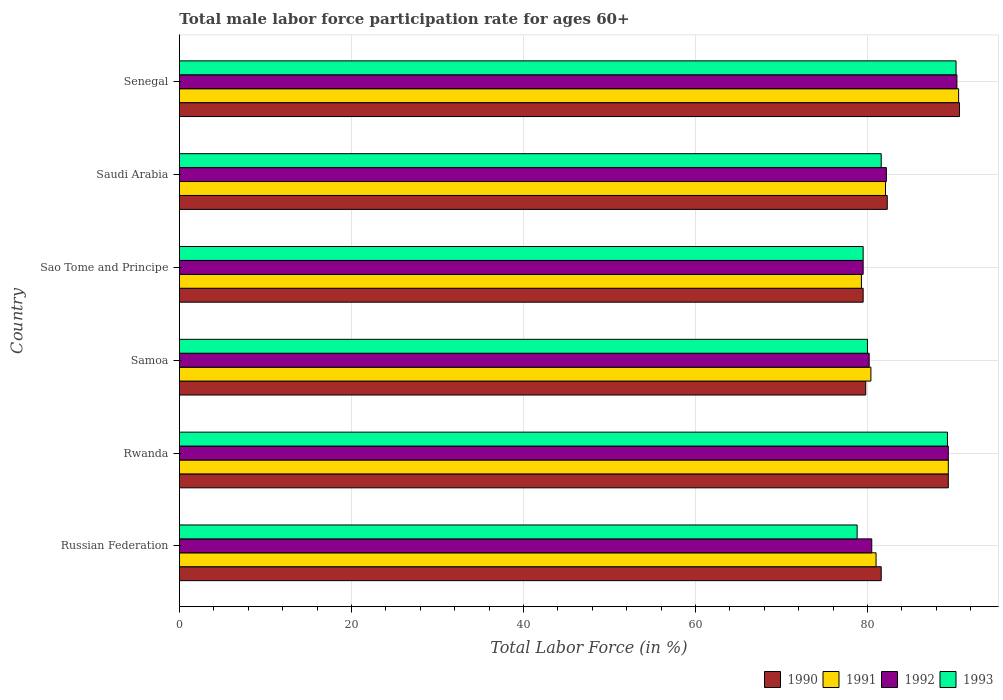How many groups of bars are there?
Offer a very short reply. 6. Are the number of bars per tick equal to the number of legend labels?
Provide a succinct answer. Yes. How many bars are there on the 6th tick from the top?
Give a very brief answer. 4. What is the label of the 4th group of bars from the top?
Keep it short and to the point. Samoa. What is the male labor force participation rate in 1993 in Senegal?
Keep it short and to the point. 90.3. Across all countries, what is the maximum male labor force participation rate in 1992?
Your response must be concise. 90.4. Across all countries, what is the minimum male labor force participation rate in 1993?
Make the answer very short. 78.8. In which country was the male labor force participation rate in 1993 maximum?
Offer a very short reply. Senegal. In which country was the male labor force participation rate in 1993 minimum?
Your answer should be compact. Russian Federation. What is the total male labor force participation rate in 1993 in the graph?
Offer a terse response. 499.5. What is the difference between the male labor force participation rate in 1992 in Samoa and that in Sao Tome and Principe?
Offer a very short reply. 0.7. What is the difference between the male labor force participation rate in 1991 in Senegal and the male labor force participation rate in 1992 in Samoa?
Your answer should be compact. 10.4. What is the average male labor force participation rate in 1992 per country?
Keep it short and to the point. 83.7. What is the difference between the male labor force participation rate in 1991 and male labor force participation rate in 1993 in Samoa?
Offer a very short reply. 0.4. What is the ratio of the male labor force participation rate in 1992 in Russian Federation to that in Saudi Arabia?
Provide a short and direct response. 0.98. What is the difference between the highest and the second highest male labor force participation rate in 1990?
Offer a very short reply. 1.3. What does the 4th bar from the top in Samoa represents?
Your answer should be compact. 1990. What does the 1st bar from the bottom in Saudi Arabia represents?
Your answer should be compact. 1990. Is it the case that in every country, the sum of the male labor force participation rate in 1992 and male labor force participation rate in 1991 is greater than the male labor force participation rate in 1990?
Ensure brevity in your answer.  Yes. How many bars are there?
Offer a very short reply. 24. How many countries are there in the graph?
Provide a short and direct response. 6. Does the graph contain grids?
Offer a terse response. Yes. Where does the legend appear in the graph?
Provide a succinct answer. Bottom right. How are the legend labels stacked?
Your answer should be very brief. Horizontal. What is the title of the graph?
Your answer should be very brief. Total male labor force participation rate for ages 60+. Does "2003" appear as one of the legend labels in the graph?
Your response must be concise. No. What is the label or title of the Y-axis?
Provide a short and direct response. Country. What is the Total Labor Force (in %) of 1990 in Russian Federation?
Keep it short and to the point. 81.6. What is the Total Labor Force (in %) in 1991 in Russian Federation?
Keep it short and to the point. 81. What is the Total Labor Force (in %) in 1992 in Russian Federation?
Ensure brevity in your answer.  80.5. What is the Total Labor Force (in %) in 1993 in Russian Federation?
Provide a short and direct response. 78.8. What is the Total Labor Force (in %) of 1990 in Rwanda?
Give a very brief answer. 89.4. What is the Total Labor Force (in %) in 1991 in Rwanda?
Your answer should be compact. 89.4. What is the Total Labor Force (in %) in 1992 in Rwanda?
Provide a succinct answer. 89.4. What is the Total Labor Force (in %) of 1993 in Rwanda?
Make the answer very short. 89.3. What is the Total Labor Force (in %) of 1990 in Samoa?
Offer a very short reply. 79.8. What is the Total Labor Force (in %) of 1991 in Samoa?
Make the answer very short. 80.4. What is the Total Labor Force (in %) of 1992 in Samoa?
Offer a terse response. 80.2. What is the Total Labor Force (in %) in 1990 in Sao Tome and Principe?
Ensure brevity in your answer.  79.5. What is the Total Labor Force (in %) in 1991 in Sao Tome and Principe?
Provide a short and direct response. 79.3. What is the Total Labor Force (in %) of 1992 in Sao Tome and Principe?
Your answer should be compact. 79.5. What is the Total Labor Force (in %) in 1993 in Sao Tome and Principe?
Provide a short and direct response. 79.5. What is the Total Labor Force (in %) in 1990 in Saudi Arabia?
Your answer should be very brief. 82.3. What is the Total Labor Force (in %) in 1991 in Saudi Arabia?
Ensure brevity in your answer.  82.1. What is the Total Labor Force (in %) in 1992 in Saudi Arabia?
Ensure brevity in your answer.  82.2. What is the Total Labor Force (in %) of 1993 in Saudi Arabia?
Give a very brief answer. 81.6. What is the Total Labor Force (in %) in 1990 in Senegal?
Offer a terse response. 90.7. What is the Total Labor Force (in %) of 1991 in Senegal?
Your response must be concise. 90.6. What is the Total Labor Force (in %) of 1992 in Senegal?
Ensure brevity in your answer.  90.4. What is the Total Labor Force (in %) in 1993 in Senegal?
Offer a terse response. 90.3. Across all countries, what is the maximum Total Labor Force (in %) in 1990?
Ensure brevity in your answer.  90.7. Across all countries, what is the maximum Total Labor Force (in %) of 1991?
Provide a short and direct response. 90.6. Across all countries, what is the maximum Total Labor Force (in %) in 1992?
Ensure brevity in your answer.  90.4. Across all countries, what is the maximum Total Labor Force (in %) in 1993?
Provide a short and direct response. 90.3. Across all countries, what is the minimum Total Labor Force (in %) of 1990?
Your response must be concise. 79.5. Across all countries, what is the minimum Total Labor Force (in %) of 1991?
Keep it short and to the point. 79.3. Across all countries, what is the minimum Total Labor Force (in %) in 1992?
Your response must be concise. 79.5. Across all countries, what is the minimum Total Labor Force (in %) in 1993?
Give a very brief answer. 78.8. What is the total Total Labor Force (in %) of 1990 in the graph?
Provide a short and direct response. 503.3. What is the total Total Labor Force (in %) of 1991 in the graph?
Your answer should be very brief. 502.8. What is the total Total Labor Force (in %) of 1992 in the graph?
Your response must be concise. 502.2. What is the total Total Labor Force (in %) of 1993 in the graph?
Keep it short and to the point. 499.5. What is the difference between the Total Labor Force (in %) of 1991 in Russian Federation and that in Rwanda?
Provide a short and direct response. -8.4. What is the difference between the Total Labor Force (in %) of 1993 in Russian Federation and that in Rwanda?
Your response must be concise. -10.5. What is the difference between the Total Labor Force (in %) in 1990 in Russian Federation and that in Samoa?
Your answer should be compact. 1.8. What is the difference between the Total Labor Force (in %) of 1990 in Russian Federation and that in Sao Tome and Principe?
Ensure brevity in your answer.  2.1. What is the difference between the Total Labor Force (in %) of 1991 in Russian Federation and that in Sao Tome and Principe?
Make the answer very short. 1.7. What is the difference between the Total Labor Force (in %) in 1992 in Russian Federation and that in Sao Tome and Principe?
Your response must be concise. 1. What is the difference between the Total Labor Force (in %) in 1993 in Russian Federation and that in Sao Tome and Principe?
Offer a terse response. -0.7. What is the difference between the Total Labor Force (in %) of 1993 in Russian Federation and that in Saudi Arabia?
Offer a very short reply. -2.8. What is the difference between the Total Labor Force (in %) in 1990 in Russian Federation and that in Senegal?
Ensure brevity in your answer.  -9.1. What is the difference between the Total Labor Force (in %) in 1991 in Russian Federation and that in Senegal?
Give a very brief answer. -9.6. What is the difference between the Total Labor Force (in %) in 1992 in Rwanda and that in Samoa?
Offer a terse response. 9.2. What is the difference between the Total Labor Force (in %) in 1990 in Rwanda and that in Sao Tome and Principe?
Keep it short and to the point. 9.9. What is the difference between the Total Labor Force (in %) of 1991 in Rwanda and that in Sao Tome and Principe?
Provide a short and direct response. 10.1. What is the difference between the Total Labor Force (in %) of 1990 in Rwanda and that in Saudi Arabia?
Your response must be concise. 7.1. What is the difference between the Total Labor Force (in %) of 1992 in Rwanda and that in Saudi Arabia?
Offer a very short reply. 7.2. What is the difference between the Total Labor Force (in %) of 1993 in Rwanda and that in Saudi Arabia?
Ensure brevity in your answer.  7.7. What is the difference between the Total Labor Force (in %) of 1990 in Rwanda and that in Senegal?
Offer a very short reply. -1.3. What is the difference between the Total Labor Force (in %) of 1991 in Rwanda and that in Senegal?
Offer a terse response. -1.2. What is the difference between the Total Labor Force (in %) in 1992 in Rwanda and that in Senegal?
Make the answer very short. -1. What is the difference between the Total Labor Force (in %) of 1990 in Samoa and that in Sao Tome and Principe?
Make the answer very short. 0.3. What is the difference between the Total Labor Force (in %) of 1993 in Samoa and that in Sao Tome and Principe?
Offer a terse response. 0.5. What is the difference between the Total Labor Force (in %) of 1990 in Samoa and that in Saudi Arabia?
Make the answer very short. -2.5. What is the difference between the Total Labor Force (in %) of 1990 in Samoa and that in Senegal?
Make the answer very short. -10.9. What is the difference between the Total Labor Force (in %) in 1992 in Samoa and that in Senegal?
Keep it short and to the point. -10.2. What is the difference between the Total Labor Force (in %) of 1990 in Sao Tome and Principe and that in Saudi Arabia?
Ensure brevity in your answer.  -2.8. What is the difference between the Total Labor Force (in %) of 1992 in Sao Tome and Principe and that in Saudi Arabia?
Make the answer very short. -2.7. What is the difference between the Total Labor Force (in %) of 1993 in Sao Tome and Principe and that in Saudi Arabia?
Provide a short and direct response. -2.1. What is the difference between the Total Labor Force (in %) in 1991 in Sao Tome and Principe and that in Senegal?
Provide a short and direct response. -11.3. What is the difference between the Total Labor Force (in %) in 1992 in Sao Tome and Principe and that in Senegal?
Offer a very short reply. -10.9. What is the difference between the Total Labor Force (in %) in 1993 in Sao Tome and Principe and that in Senegal?
Your response must be concise. -10.8. What is the difference between the Total Labor Force (in %) of 1991 in Saudi Arabia and that in Senegal?
Keep it short and to the point. -8.5. What is the difference between the Total Labor Force (in %) in 1992 in Saudi Arabia and that in Senegal?
Make the answer very short. -8.2. What is the difference between the Total Labor Force (in %) of 1993 in Saudi Arabia and that in Senegal?
Your response must be concise. -8.7. What is the difference between the Total Labor Force (in %) in 1990 in Russian Federation and the Total Labor Force (in %) in 1992 in Rwanda?
Ensure brevity in your answer.  -7.8. What is the difference between the Total Labor Force (in %) in 1990 in Russian Federation and the Total Labor Force (in %) in 1993 in Rwanda?
Offer a very short reply. -7.7. What is the difference between the Total Labor Force (in %) of 1991 in Russian Federation and the Total Labor Force (in %) of 1993 in Rwanda?
Provide a succinct answer. -8.3. What is the difference between the Total Labor Force (in %) in 1990 in Russian Federation and the Total Labor Force (in %) in 1992 in Samoa?
Offer a very short reply. 1.4. What is the difference between the Total Labor Force (in %) of 1991 in Russian Federation and the Total Labor Force (in %) of 1992 in Samoa?
Your response must be concise. 0.8. What is the difference between the Total Labor Force (in %) of 1992 in Russian Federation and the Total Labor Force (in %) of 1993 in Samoa?
Provide a short and direct response. 0.5. What is the difference between the Total Labor Force (in %) of 1990 in Russian Federation and the Total Labor Force (in %) of 1992 in Sao Tome and Principe?
Offer a very short reply. 2.1. What is the difference between the Total Labor Force (in %) in 1990 in Russian Federation and the Total Labor Force (in %) in 1993 in Sao Tome and Principe?
Provide a succinct answer. 2.1. What is the difference between the Total Labor Force (in %) in 1991 in Russian Federation and the Total Labor Force (in %) in 1992 in Sao Tome and Principe?
Your answer should be very brief. 1.5. What is the difference between the Total Labor Force (in %) in 1991 in Russian Federation and the Total Labor Force (in %) in 1993 in Sao Tome and Principe?
Offer a very short reply. 1.5. What is the difference between the Total Labor Force (in %) in 1990 in Russian Federation and the Total Labor Force (in %) in 1991 in Saudi Arabia?
Give a very brief answer. -0.5. What is the difference between the Total Labor Force (in %) in 1990 in Russian Federation and the Total Labor Force (in %) in 1992 in Saudi Arabia?
Offer a terse response. -0.6. What is the difference between the Total Labor Force (in %) of 1990 in Russian Federation and the Total Labor Force (in %) of 1993 in Saudi Arabia?
Ensure brevity in your answer.  0. What is the difference between the Total Labor Force (in %) in 1991 in Russian Federation and the Total Labor Force (in %) in 1992 in Saudi Arabia?
Your response must be concise. -1.2. What is the difference between the Total Labor Force (in %) in 1992 in Russian Federation and the Total Labor Force (in %) in 1993 in Saudi Arabia?
Give a very brief answer. -1.1. What is the difference between the Total Labor Force (in %) of 1990 in Russian Federation and the Total Labor Force (in %) of 1991 in Senegal?
Provide a short and direct response. -9. What is the difference between the Total Labor Force (in %) of 1990 in Russian Federation and the Total Labor Force (in %) of 1992 in Senegal?
Offer a very short reply. -8.8. What is the difference between the Total Labor Force (in %) of 1991 in Russian Federation and the Total Labor Force (in %) of 1993 in Senegal?
Your response must be concise. -9.3. What is the difference between the Total Labor Force (in %) in 1990 in Rwanda and the Total Labor Force (in %) in 1992 in Samoa?
Offer a very short reply. 9.2. What is the difference between the Total Labor Force (in %) in 1990 in Rwanda and the Total Labor Force (in %) in 1993 in Samoa?
Your response must be concise. 9.4. What is the difference between the Total Labor Force (in %) in 1991 in Rwanda and the Total Labor Force (in %) in 1993 in Samoa?
Ensure brevity in your answer.  9.4. What is the difference between the Total Labor Force (in %) in 1990 in Rwanda and the Total Labor Force (in %) in 1991 in Sao Tome and Principe?
Ensure brevity in your answer.  10.1. What is the difference between the Total Labor Force (in %) in 1990 in Rwanda and the Total Labor Force (in %) in 1992 in Saudi Arabia?
Your answer should be compact. 7.2. What is the difference between the Total Labor Force (in %) of 1992 in Rwanda and the Total Labor Force (in %) of 1993 in Saudi Arabia?
Ensure brevity in your answer.  7.8. What is the difference between the Total Labor Force (in %) of 1990 in Rwanda and the Total Labor Force (in %) of 1991 in Senegal?
Make the answer very short. -1.2. What is the difference between the Total Labor Force (in %) of 1990 in Rwanda and the Total Labor Force (in %) of 1992 in Senegal?
Your answer should be very brief. -1. What is the difference between the Total Labor Force (in %) in 1990 in Rwanda and the Total Labor Force (in %) in 1993 in Senegal?
Give a very brief answer. -0.9. What is the difference between the Total Labor Force (in %) of 1992 in Rwanda and the Total Labor Force (in %) of 1993 in Senegal?
Keep it short and to the point. -0.9. What is the difference between the Total Labor Force (in %) in 1992 in Samoa and the Total Labor Force (in %) in 1993 in Sao Tome and Principe?
Offer a very short reply. 0.7. What is the difference between the Total Labor Force (in %) of 1990 in Samoa and the Total Labor Force (in %) of 1991 in Saudi Arabia?
Provide a short and direct response. -2.3. What is the difference between the Total Labor Force (in %) in 1990 in Samoa and the Total Labor Force (in %) in 1992 in Saudi Arabia?
Ensure brevity in your answer.  -2.4. What is the difference between the Total Labor Force (in %) in 1991 in Samoa and the Total Labor Force (in %) in 1993 in Saudi Arabia?
Keep it short and to the point. -1.2. What is the difference between the Total Labor Force (in %) in 1990 in Samoa and the Total Labor Force (in %) in 1993 in Senegal?
Offer a very short reply. -10.5. What is the difference between the Total Labor Force (in %) in 1991 in Samoa and the Total Labor Force (in %) in 1992 in Senegal?
Provide a succinct answer. -10. What is the difference between the Total Labor Force (in %) of 1990 in Sao Tome and Principe and the Total Labor Force (in %) of 1993 in Saudi Arabia?
Keep it short and to the point. -2.1. What is the difference between the Total Labor Force (in %) of 1992 in Sao Tome and Principe and the Total Labor Force (in %) of 1993 in Saudi Arabia?
Your answer should be compact. -2.1. What is the difference between the Total Labor Force (in %) of 1990 in Sao Tome and Principe and the Total Labor Force (in %) of 1991 in Senegal?
Offer a terse response. -11.1. What is the difference between the Total Labor Force (in %) in 1990 in Sao Tome and Principe and the Total Labor Force (in %) in 1992 in Senegal?
Make the answer very short. -10.9. What is the difference between the Total Labor Force (in %) of 1991 in Sao Tome and Principe and the Total Labor Force (in %) of 1993 in Senegal?
Your answer should be compact. -11. What is the difference between the Total Labor Force (in %) in 1990 in Saudi Arabia and the Total Labor Force (in %) in 1992 in Senegal?
Make the answer very short. -8.1. What is the difference between the Total Labor Force (in %) in 1990 in Saudi Arabia and the Total Labor Force (in %) in 1993 in Senegal?
Your answer should be compact. -8. What is the difference between the Total Labor Force (in %) of 1991 in Saudi Arabia and the Total Labor Force (in %) of 1992 in Senegal?
Your answer should be very brief. -8.3. What is the average Total Labor Force (in %) of 1990 per country?
Ensure brevity in your answer.  83.88. What is the average Total Labor Force (in %) of 1991 per country?
Offer a terse response. 83.8. What is the average Total Labor Force (in %) of 1992 per country?
Make the answer very short. 83.7. What is the average Total Labor Force (in %) of 1993 per country?
Make the answer very short. 83.25. What is the difference between the Total Labor Force (in %) of 1990 and Total Labor Force (in %) of 1992 in Russian Federation?
Ensure brevity in your answer.  1.1. What is the difference between the Total Labor Force (in %) in 1990 and Total Labor Force (in %) in 1993 in Russian Federation?
Offer a terse response. 2.8. What is the difference between the Total Labor Force (in %) in 1991 and Total Labor Force (in %) in 1993 in Russian Federation?
Make the answer very short. 2.2. What is the difference between the Total Labor Force (in %) in 1990 and Total Labor Force (in %) in 1992 in Rwanda?
Provide a succinct answer. 0. What is the difference between the Total Labor Force (in %) in 1991 and Total Labor Force (in %) in 1992 in Rwanda?
Offer a very short reply. 0. What is the difference between the Total Labor Force (in %) in 1991 and Total Labor Force (in %) in 1993 in Rwanda?
Offer a very short reply. 0.1. What is the difference between the Total Labor Force (in %) in 1990 and Total Labor Force (in %) in 1992 in Samoa?
Make the answer very short. -0.4. What is the difference between the Total Labor Force (in %) of 1991 and Total Labor Force (in %) of 1993 in Samoa?
Provide a succinct answer. 0.4. What is the difference between the Total Labor Force (in %) of 1992 and Total Labor Force (in %) of 1993 in Samoa?
Your response must be concise. 0.2. What is the difference between the Total Labor Force (in %) of 1990 and Total Labor Force (in %) of 1991 in Sao Tome and Principe?
Ensure brevity in your answer.  0.2. What is the difference between the Total Labor Force (in %) in 1990 and Total Labor Force (in %) in 1992 in Sao Tome and Principe?
Provide a short and direct response. 0. What is the difference between the Total Labor Force (in %) in 1991 and Total Labor Force (in %) in 1993 in Sao Tome and Principe?
Your answer should be very brief. -0.2. What is the difference between the Total Labor Force (in %) of 1992 and Total Labor Force (in %) of 1993 in Sao Tome and Principe?
Your answer should be very brief. 0. What is the difference between the Total Labor Force (in %) in 1990 and Total Labor Force (in %) in 1993 in Saudi Arabia?
Your answer should be compact. 0.7. What is the difference between the Total Labor Force (in %) of 1991 and Total Labor Force (in %) of 1993 in Saudi Arabia?
Provide a succinct answer. 0.5. What is the difference between the Total Labor Force (in %) in 1990 and Total Labor Force (in %) in 1992 in Senegal?
Your response must be concise. 0.3. What is the difference between the Total Labor Force (in %) in 1991 and Total Labor Force (in %) in 1992 in Senegal?
Your response must be concise. 0.2. What is the difference between the Total Labor Force (in %) in 1991 and Total Labor Force (in %) in 1993 in Senegal?
Make the answer very short. 0.3. What is the difference between the Total Labor Force (in %) in 1992 and Total Labor Force (in %) in 1993 in Senegal?
Ensure brevity in your answer.  0.1. What is the ratio of the Total Labor Force (in %) in 1990 in Russian Federation to that in Rwanda?
Provide a short and direct response. 0.91. What is the ratio of the Total Labor Force (in %) in 1991 in Russian Federation to that in Rwanda?
Keep it short and to the point. 0.91. What is the ratio of the Total Labor Force (in %) in 1992 in Russian Federation to that in Rwanda?
Give a very brief answer. 0.9. What is the ratio of the Total Labor Force (in %) in 1993 in Russian Federation to that in Rwanda?
Your response must be concise. 0.88. What is the ratio of the Total Labor Force (in %) in 1990 in Russian Federation to that in Samoa?
Your answer should be very brief. 1.02. What is the ratio of the Total Labor Force (in %) in 1991 in Russian Federation to that in Samoa?
Offer a terse response. 1.01. What is the ratio of the Total Labor Force (in %) of 1992 in Russian Federation to that in Samoa?
Your answer should be compact. 1. What is the ratio of the Total Labor Force (in %) of 1990 in Russian Federation to that in Sao Tome and Principe?
Provide a succinct answer. 1.03. What is the ratio of the Total Labor Force (in %) in 1991 in Russian Federation to that in Sao Tome and Principe?
Offer a very short reply. 1.02. What is the ratio of the Total Labor Force (in %) of 1992 in Russian Federation to that in Sao Tome and Principe?
Offer a very short reply. 1.01. What is the ratio of the Total Labor Force (in %) of 1990 in Russian Federation to that in Saudi Arabia?
Make the answer very short. 0.99. What is the ratio of the Total Labor Force (in %) in 1991 in Russian Federation to that in Saudi Arabia?
Your response must be concise. 0.99. What is the ratio of the Total Labor Force (in %) in 1992 in Russian Federation to that in Saudi Arabia?
Make the answer very short. 0.98. What is the ratio of the Total Labor Force (in %) in 1993 in Russian Federation to that in Saudi Arabia?
Make the answer very short. 0.97. What is the ratio of the Total Labor Force (in %) of 1990 in Russian Federation to that in Senegal?
Offer a terse response. 0.9. What is the ratio of the Total Labor Force (in %) of 1991 in Russian Federation to that in Senegal?
Offer a very short reply. 0.89. What is the ratio of the Total Labor Force (in %) in 1992 in Russian Federation to that in Senegal?
Give a very brief answer. 0.89. What is the ratio of the Total Labor Force (in %) in 1993 in Russian Federation to that in Senegal?
Make the answer very short. 0.87. What is the ratio of the Total Labor Force (in %) of 1990 in Rwanda to that in Samoa?
Provide a succinct answer. 1.12. What is the ratio of the Total Labor Force (in %) in 1991 in Rwanda to that in Samoa?
Give a very brief answer. 1.11. What is the ratio of the Total Labor Force (in %) of 1992 in Rwanda to that in Samoa?
Offer a terse response. 1.11. What is the ratio of the Total Labor Force (in %) of 1993 in Rwanda to that in Samoa?
Your answer should be very brief. 1.12. What is the ratio of the Total Labor Force (in %) of 1990 in Rwanda to that in Sao Tome and Principe?
Your answer should be very brief. 1.12. What is the ratio of the Total Labor Force (in %) of 1991 in Rwanda to that in Sao Tome and Principe?
Give a very brief answer. 1.13. What is the ratio of the Total Labor Force (in %) in 1992 in Rwanda to that in Sao Tome and Principe?
Your response must be concise. 1.12. What is the ratio of the Total Labor Force (in %) of 1993 in Rwanda to that in Sao Tome and Principe?
Offer a terse response. 1.12. What is the ratio of the Total Labor Force (in %) of 1990 in Rwanda to that in Saudi Arabia?
Provide a succinct answer. 1.09. What is the ratio of the Total Labor Force (in %) of 1991 in Rwanda to that in Saudi Arabia?
Keep it short and to the point. 1.09. What is the ratio of the Total Labor Force (in %) of 1992 in Rwanda to that in Saudi Arabia?
Offer a very short reply. 1.09. What is the ratio of the Total Labor Force (in %) of 1993 in Rwanda to that in Saudi Arabia?
Ensure brevity in your answer.  1.09. What is the ratio of the Total Labor Force (in %) of 1990 in Rwanda to that in Senegal?
Provide a succinct answer. 0.99. What is the ratio of the Total Labor Force (in %) in 1992 in Rwanda to that in Senegal?
Your response must be concise. 0.99. What is the ratio of the Total Labor Force (in %) of 1993 in Rwanda to that in Senegal?
Your response must be concise. 0.99. What is the ratio of the Total Labor Force (in %) of 1991 in Samoa to that in Sao Tome and Principe?
Your answer should be compact. 1.01. What is the ratio of the Total Labor Force (in %) of 1992 in Samoa to that in Sao Tome and Principe?
Offer a very short reply. 1.01. What is the ratio of the Total Labor Force (in %) in 1990 in Samoa to that in Saudi Arabia?
Make the answer very short. 0.97. What is the ratio of the Total Labor Force (in %) of 1991 in Samoa to that in Saudi Arabia?
Give a very brief answer. 0.98. What is the ratio of the Total Labor Force (in %) of 1992 in Samoa to that in Saudi Arabia?
Your response must be concise. 0.98. What is the ratio of the Total Labor Force (in %) in 1993 in Samoa to that in Saudi Arabia?
Give a very brief answer. 0.98. What is the ratio of the Total Labor Force (in %) in 1990 in Samoa to that in Senegal?
Your response must be concise. 0.88. What is the ratio of the Total Labor Force (in %) of 1991 in Samoa to that in Senegal?
Offer a very short reply. 0.89. What is the ratio of the Total Labor Force (in %) in 1992 in Samoa to that in Senegal?
Your response must be concise. 0.89. What is the ratio of the Total Labor Force (in %) of 1993 in Samoa to that in Senegal?
Your answer should be compact. 0.89. What is the ratio of the Total Labor Force (in %) in 1990 in Sao Tome and Principe to that in Saudi Arabia?
Your response must be concise. 0.97. What is the ratio of the Total Labor Force (in %) in 1991 in Sao Tome and Principe to that in Saudi Arabia?
Provide a succinct answer. 0.97. What is the ratio of the Total Labor Force (in %) in 1992 in Sao Tome and Principe to that in Saudi Arabia?
Offer a terse response. 0.97. What is the ratio of the Total Labor Force (in %) in 1993 in Sao Tome and Principe to that in Saudi Arabia?
Your response must be concise. 0.97. What is the ratio of the Total Labor Force (in %) of 1990 in Sao Tome and Principe to that in Senegal?
Offer a terse response. 0.88. What is the ratio of the Total Labor Force (in %) in 1991 in Sao Tome and Principe to that in Senegal?
Make the answer very short. 0.88. What is the ratio of the Total Labor Force (in %) of 1992 in Sao Tome and Principe to that in Senegal?
Your answer should be compact. 0.88. What is the ratio of the Total Labor Force (in %) of 1993 in Sao Tome and Principe to that in Senegal?
Provide a succinct answer. 0.88. What is the ratio of the Total Labor Force (in %) in 1990 in Saudi Arabia to that in Senegal?
Give a very brief answer. 0.91. What is the ratio of the Total Labor Force (in %) in 1991 in Saudi Arabia to that in Senegal?
Provide a succinct answer. 0.91. What is the ratio of the Total Labor Force (in %) in 1992 in Saudi Arabia to that in Senegal?
Ensure brevity in your answer.  0.91. What is the ratio of the Total Labor Force (in %) of 1993 in Saudi Arabia to that in Senegal?
Your answer should be compact. 0.9. What is the difference between the highest and the second highest Total Labor Force (in %) in 1990?
Offer a very short reply. 1.3. What is the difference between the highest and the second highest Total Labor Force (in %) of 1991?
Ensure brevity in your answer.  1.2. What is the difference between the highest and the second highest Total Labor Force (in %) of 1992?
Your answer should be compact. 1. What is the difference between the highest and the second highest Total Labor Force (in %) in 1993?
Your answer should be compact. 1. What is the difference between the highest and the lowest Total Labor Force (in %) in 1990?
Provide a short and direct response. 11.2. 